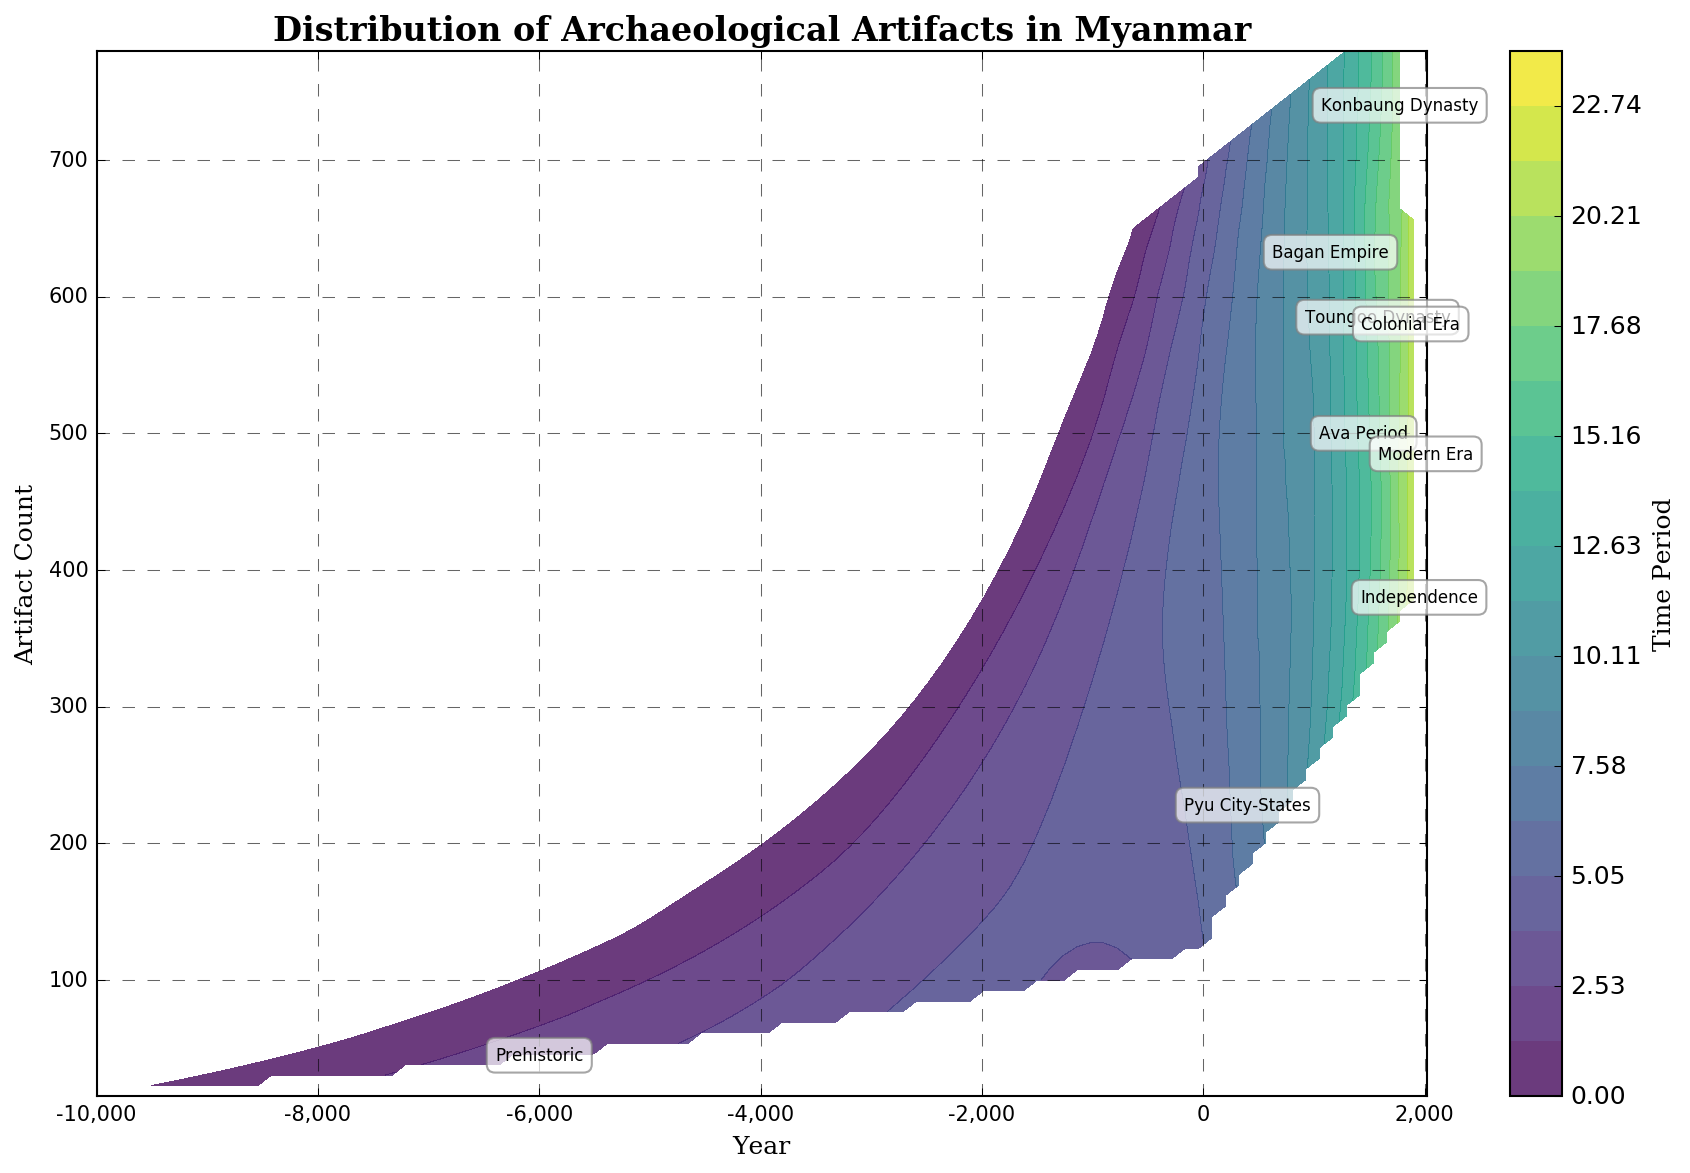What time period has the highest artifact count peak? By looking at the contour levels and noting the maximum height on the y-axis, we see that the Bagan Empire period shows the highest number of artifacts.
Answer: Bagan Empire What was the artifact count around the year 0, and how does it compare to the count around 1000 AD? Around the year 0, the artifact count is around 120. Around 1000 AD, it peaks at around 450 artifacts. By comparing these numbers, we see a significant increase.
Answer: 120 vs 450, increase What color represents the time period "Pyu City-States" on the contour plot? By checking the color bar and examining the associated level for "Pyu City-States," we note that this time period is represented by a gradient moving towards the middle of the color spectrum, typically colors like green in the 'viridis' colormap.
Answer: Green Which time period corresponds to the steepest increase in artifact count? By analyzing the contours and noting the steep gradient areas, the transition between the Prehistoric period and the Pyu City-States shows the most rapid increase in artifact count.
Answer: Prehistoric to Pyu City-States By how much did the artifact count change from the peak of the Toungoo Dynasty to the Colonial Era? The peak of the Toungoo Dynasty is around 620 artifacts, while the Colonial Era peaks at around 620 artifacts. We notice no change in artifact count peaks between these periods.
Answer: 0 What year and artifact count correspond closely to the label for the "Ava Period"? By looking at the annotation for the Ava Period, it is placed around a year near 1450 and an artifact count near 500.
Answer: 1450, 500 How does the artifact count in the Modern Era (2000s) compare to that of the Independence period (1950)? The artifact count in the Modern Era (2000s) is around 450, whereas in the Independence period (1950) it is around 380. This shows an increase of about 70 artifacts from Independence to Modern Era.
Answer: Increase by 70 